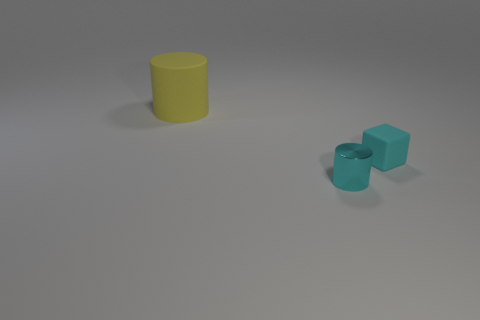Is there any other thing that is the same size as the yellow rubber thing?
Provide a succinct answer. No. There is a tiny thing on the right side of the tiny shiny cylinder; does it have the same color as the metal thing?
Provide a succinct answer. Yes. What number of yellow rubber things are the same shape as the tiny shiny object?
Offer a terse response. 1. What number of objects are things behind the cyan shiny thing or small objects in front of the cyan rubber thing?
Make the answer very short. 3. What number of cyan things are either tiny objects or tiny matte cylinders?
Provide a succinct answer. 2. The thing that is to the right of the large matte cylinder and behind the tiny cyan cylinder is made of what material?
Offer a terse response. Rubber. Is the large yellow cylinder made of the same material as the small cyan block?
Make the answer very short. Yes. How many cyan metal objects are the same size as the matte cylinder?
Your answer should be compact. 0. Is the number of big yellow matte objects that are on the right side of the cyan shiny thing the same as the number of big yellow cylinders?
Keep it short and to the point. No. How many objects are behind the shiny cylinder and to the right of the yellow matte object?
Keep it short and to the point. 1. 